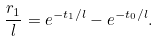<formula> <loc_0><loc_0><loc_500><loc_500>\frac { r _ { 1 } } { l } = e ^ { - t _ { 1 } / l } - e ^ { - t _ { 0 } / l } .</formula> 